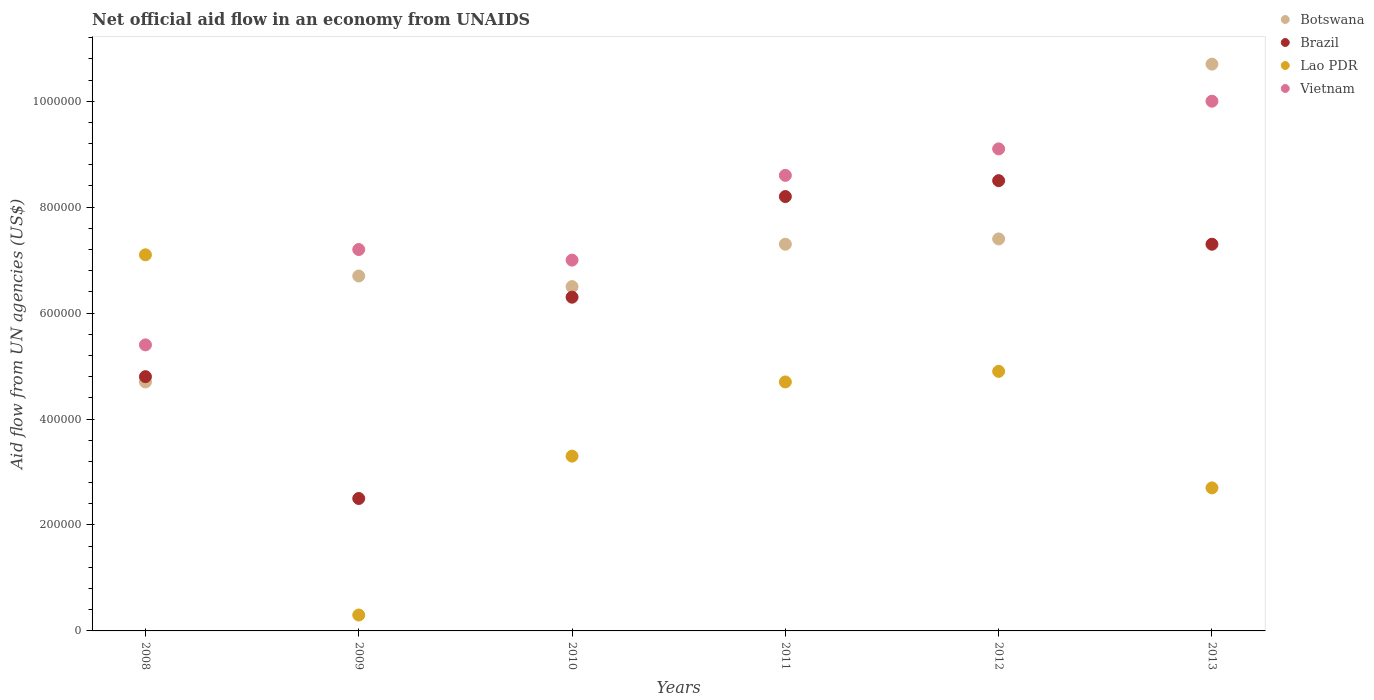How many different coloured dotlines are there?
Make the answer very short. 4. What is the net official aid flow in Lao PDR in 2008?
Provide a short and direct response. 7.10e+05. Across all years, what is the maximum net official aid flow in Botswana?
Offer a very short reply. 1.07e+06. Across all years, what is the minimum net official aid flow in Lao PDR?
Give a very brief answer. 3.00e+04. What is the total net official aid flow in Vietnam in the graph?
Ensure brevity in your answer.  4.73e+06. What is the difference between the net official aid flow in Botswana in 2009 and that in 2012?
Provide a short and direct response. -7.00e+04. What is the difference between the net official aid flow in Brazil in 2008 and the net official aid flow in Botswana in 2012?
Provide a succinct answer. -2.60e+05. What is the average net official aid flow in Vietnam per year?
Provide a succinct answer. 7.88e+05. In the year 2010, what is the difference between the net official aid flow in Brazil and net official aid flow in Vietnam?
Keep it short and to the point. -7.00e+04. What is the ratio of the net official aid flow in Vietnam in 2008 to that in 2012?
Offer a terse response. 0.59. Is the net official aid flow in Botswana in 2011 less than that in 2012?
Your answer should be very brief. Yes. Is the difference between the net official aid flow in Brazil in 2009 and 2011 greater than the difference between the net official aid flow in Vietnam in 2009 and 2011?
Your response must be concise. No. What is the difference between the highest and the second highest net official aid flow in Vietnam?
Your answer should be compact. 9.00e+04. What is the difference between the highest and the lowest net official aid flow in Vietnam?
Your response must be concise. 4.60e+05. In how many years, is the net official aid flow in Botswana greater than the average net official aid flow in Botswana taken over all years?
Provide a short and direct response. 3. Is the sum of the net official aid flow in Botswana in 2008 and 2010 greater than the maximum net official aid flow in Vietnam across all years?
Offer a very short reply. Yes. Is it the case that in every year, the sum of the net official aid flow in Brazil and net official aid flow in Vietnam  is greater than the net official aid flow in Lao PDR?
Make the answer very short. Yes. Is the net official aid flow in Vietnam strictly greater than the net official aid flow in Brazil over the years?
Keep it short and to the point. Yes. What is the difference between two consecutive major ticks on the Y-axis?
Provide a short and direct response. 2.00e+05. Does the graph contain grids?
Give a very brief answer. No. How many legend labels are there?
Your answer should be compact. 4. How are the legend labels stacked?
Offer a very short reply. Vertical. What is the title of the graph?
Your answer should be very brief. Net official aid flow in an economy from UNAIDS. What is the label or title of the X-axis?
Ensure brevity in your answer.  Years. What is the label or title of the Y-axis?
Your response must be concise. Aid flow from UN agencies (US$). What is the Aid flow from UN agencies (US$) in Botswana in 2008?
Offer a very short reply. 4.70e+05. What is the Aid flow from UN agencies (US$) in Brazil in 2008?
Make the answer very short. 4.80e+05. What is the Aid flow from UN agencies (US$) of Lao PDR in 2008?
Make the answer very short. 7.10e+05. What is the Aid flow from UN agencies (US$) in Vietnam in 2008?
Your answer should be very brief. 5.40e+05. What is the Aid flow from UN agencies (US$) in Botswana in 2009?
Give a very brief answer. 6.70e+05. What is the Aid flow from UN agencies (US$) of Lao PDR in 2009?
Provide a succinct answer. 3.00e+04. What is the Aid flow from UN agencies (US$) in Vietnam in 2009?
Provide a succinct answer. 7.20e+05. What is the Aid flow from UN agencies (US$) of Botswana in 2010?
Provide a short and direct response. 6.50e+05. What is the Aid flow from UN agencies (US$) of Brazil in 2010?
Your answer should be compact. 6.30e+05. What is the Aid flow from UN agencies (US$) of Lao PDR in 2010?
Keep it short and to the point. 3.30e+05. What is the Aid flow from UN agencies (US$) in Botswana in 2011?
Provide a short and direct response. 7.30e+05. What is the Aid flow from UN agencies (US$) in Brazil in 2011?
Ensure brevity in your answer.  8.20e+05. What is the Aid flow from UN agencies (US$) in Vietnam in 2011?
Provide a short and direct response. 8.60e+05. What is the Aid flow from UN agencies (US$) in Botswana in 2012?
Offer a very short reply. 7.40e+05. What is the Aid flow from UN agencies (US$) of Brazil in 2012?
Offer a very short reply. 8.50e+05. What is the Aid flow from UN agencies (US$) of Vietnam in 2012?
Provide a succinct answer. 9.10e+05. What is the Aid flow from UN agencies (US$) of Botswana in 2013?
Keep it short and to the point. 1.07e+06. What is the Aid flow from UN agencies (US$) of Brazil in 2013?
Your answer should be very brief. 7.30e+05. What is the Aid flow from UN agencies (US$) of Vietnam in 2013?
Offer a terse response. 1.00e+06. Across all years, what is the maximum Aid flow from UN agencies (US$) of Botswana?
Offer a very short reply. 1.07e+06. Across all years, what is the maximum Aid flow from UN agencies (US$) of Brazil?
Provide a short and direct response. 8.50e+05. Across all years, what is the maximum Aid flow from UN agencies (US$) in Lao PDR?
Your answer should be compact. 7.10e+05. Across all years, what is the maximum Aid flow from UN agencies (US$) in Vietnam?
Your answer should be very brief. 1.00e+06. Across all years, what is the minimum Aid flow from UN agencies (US$) in Botswana?
Provide a short and direct response. 4.70e+05. Across all years, what is the minimum Aid flow from UN agencies (US$) in Brazil?
Make the answer very short. 2.50e+05. Across all years, what is the minimum Aid flow from UN agencies (US$) of Lao PDR?
Offer a very short reply. 3.00e+04. Across all years, what is the minimum Aid flow from UN agencies (US$) of Vietnam?
Your response must be concise. 5.40e+05. What is the total Aid flow from UN agencies (US$) of Botswana in the graph?
Your answer should be very brief. 4.33e+06. What is the total Aid flow from UN agencies (US$) of Brazil in the graph?
Provide a succinct answer. 3.76e+06. What is the total Aid flow from UN agencies (US$) in Lao PDR in the graph?
Offer a terse response. 2.30e+06. What is the total Aid flow from UN agencies (US$) of Vietnam in the graph?
Provide a succinct answer. 4.73e+06. What is the difference between the Aid flow from UN agencies (US$) of Lao PDR in 2008 and that in 2009?
Offer a terse response. 6.80e+05. What is the difference between the Aid flow from UN agencies (US$) of Vietnam in 2008 and that in 2009?
Your response must be concise. -1.80e+05. What is the difference between the Aid flow from UN agencies (US$) in Lao PDR in 2008 and that in 2010?
Your response must be concise. 3.80e+05. What is the difference between the Aid flow from UN agencies (US$) in Vietnam in 2008 and that in 2010?
Your response must be concise. -1.60e+05. What is the difference between the Aid flow from UN agencies (US$) of Botswana in 2008 and that in 2011?
Your response must be concise. -2.60e+05. What is the difference between the Aid flow from UN agencies (US$) of Vietnam in 2008 and that in 2011?
Provide a succinct answer. -3.20e+05. What is the difference between the Aid flow from UN agencies (US$) of Botswana in 2008 and that in 2012?
Your answer should be compact. -2.70e+05. What is the difference between the Aid flow from UN agencies (US$) in Brazil in 2008 and that in 2012?
Your answer should be compact. -3.70e+05. What is the difference between the Aid flow from UN agencies (US$) in Lao PDR in 2008 and that in 2012?
Your answer should be compact. 2.20e+05. What is the difference between the Aid flow from UN agencies (US$) of Vietnam in 2008 and that in 2012?
Your answer should be compact. -3.70e+05. What is the difference between the Aid flow from UN agencies (US$) of Botswana in 2008 and that in 2013?
Your response must be concise. -6.00e+05. What is the difference between the Aid flow from UN agencies (US$) of Brazil in 2008 and that in 2013?
Offer a terse response. -2.50e+05. What is the difference between the Aid flow from UN agencies (US$) of Vietnam in 2008 and that in 2013?
Your answer should be compact. -4.60e+05. What is the difference between the Aid flow from UN agencies (US$) in Botswana in 2009 and that in 2010?
Offer a terse response. 2.00e+04. What is the difference between the Aid flow from UN agencies (US$) in Brazil in 2009 and that in 2010?
Your answer should be compact. -3.80e+05. What is the difference between the Aid flow from UN agencies (US$) of Lao PDR in 2009 and that in 2010?
Provide a short and direct response. -3.00e+05. What is the difference between the Aid flow from UN agencies (US$) in Vietnam in 2009 and that in 2010?
Ensure brevity in your answer.  2.00e+04. What is the difference between the Aid flow from UN agencies (US$) in Brazil in 2009 and that in 2011?
Make the answer very short. -5.70e+05. What is the difference between the Aid flow from UN agencies (US$) in Lao PDR in 2009 and that in 2011?
Ensure brevity in your answer.  -4.40e+05. What is the difference between the Aid flow from UN agencies (US$) in Vietnam in 2009 and that in 2011?
Your answer should be very brief. -1.40e+05. What is the difference between the Aid flow from UN agencies (US$) of Brazil in 2009 and that in 2012?
Your answer should be very brief. -6.00e+05. What is the difference between the Aid flow from UN agencies (US$) of Lao PDR in 2009 and that in 2012?
Provide a short and direct response. -4.60e+05. What is the difference between the Aid flow from UN agencies (US$) in Botswana in 2009 and that in 2013?
Your answer should be compact. -4.00e+05. What is the difference between the Aid flow from UN agencies (US$) of Brazil in 2009 and that in 2013?
Your answer should be very brief. -4.80e+05. What is the difference between the Aid flow from UN agencies (US$) of Lao PDR in 2009 and that in 2013?
Keep it short and to the point. -2.40e+05. What is the difference between the Aid flow from UN agencies (US$) of Vietnam in 2009 and that in 2013?
Give a very brief answer. -2.80e+05. What is the difference between the Aid flow from UN agencies (US$) in Brazil in 2010 and that in 2011?
Your answer should be compact. -1.90e+05. What is the difference between the Aid flow from UN agencies (US$) of Lao PDR in 2010 and that in 2011?
Provide a short and direct response. -1.40e+05. What is the difference between the Aid flow from UN agencies (US$) in Botswana in 2010 and that in 2012?
Your answer should be compact. -9.00e+04. What is the difference between the Aid flow from UN agencies (US$) of Lao PDR in 2010 and that in 2012?
Offer a very short reply. -1.60e+05. What is the difference between the Aid flow from UN agencies (US$) of Botswana in 2010 and that in 2013?
Your answer should be compact. -4.20e+05. What is the difference between the Aid flow from UN agencies (US$) of Lao PDR in 2010 and that in 2013?
Offer a terse response. 6.00e+04. What is the difference between the Aid flow from UN agencies (US$) of Botswana in 2011 and that in 2012?
Keep it short and to the point. -10000. What is the difference between the Aid flow from UN agencies (US$) of Lao PDR in 2011 and that in 2012?
Give a very brief answer. -2.00e+04. What is the difference between the Aid flow from UN agencies (US$) in Vietnam in 2011 and that in 2012?
Provide a succinct answer. -5.00e+04. What is the difference between the Aid flow from UN agencies (US$) in Botswana in 2011 and that in 2013?
Make the answer very short. -3.40e+05. What is the difference between the Aid flow from UN agencies (US$) of Vietnam in 2011 and that in 2013?
Offer a very short reply. -1.40e+05. What is the difference between the Aid flow from UN agencies (US$) in Botswana in 2012 and that in 2013?
Keep it short and to the point. -3.30e+05. What is the difference between the Aid flow from UN agencies (US$) in Vietnam in 2012 and that in 2013?
Offer a very short reply. -9.00e+04. What is the difference between the Aid flow from UN agencies (US$) of Botswana in 2008 and the Aid flow from UN agencies (US$) of Brazil in 2009?
Offer a very short reply. 2.20e+05. What is the difference between the Aid flow from UN agencies (US$) of Brazil in 2008 and the Aid flow from UN agencies (US$) of Lao PDR in 2009?
Provide a short and direct response. 4.50e+05. What is the difference between the Aid flow from UN agencies (US$) in Lao PDR in 2008 and the Aid flow from UN agencies (US$) in Vietnam in 2009?
Your response must be concise. -10000. What is the difference between the Aid flow from UN agencies (US$) of Botswana in 2008 and the Aid flow from UN agencies (US$) of Lao PDR in 2010?
Give a very brief answer. 1.40e+05. What is the difference between the Aid flow from UN agencies (US$) of Botswana in 2008 and the Aid flow from UN agencies (US$) of Brazil in 2011?
Provide a short and direct response. -3.50e+05. What is the difference between the Aid flow from UN agencies (US$) in Botswana in 2008 and the Aid flow from UN agencies (US$) in Lao PDR in 2011?
Your response must be concise. 0. What is the difference between the Aid flow from UN agencies (US$) of Botswana in 2008 and the Aid flow from UN agencies (US$) of Vietnam in 2011?
Your response must be concise. -3.90e+05. What is the difference between the Aid flow from UN agencies (US$) of Brazil in 2008 and the Aid flow from UN agencies (US$) of Vietnam in 2011?
Offer a terse response. -3.80e+05. What is the difference between the Aid flow from UN agencies (US$) of Lao PDR in 2008 and the Aid flow from UN agencies (US$) of Vietnam in 2011?
Your answer should be very brief. -1.50e+05. What is the difference between the Aid flow from UN agencies (US$) in Botswana in 2008 and the Aid flow from UN agencies (US$) in Brazil in 2012?
Provide a short and direct response. -3.80e+05. What is the difference between the Aid flow from UN agencies (US$) in Botswana in 2008 and the Aid flow from UN agencies (US$) in Vietnam in 2012?
Provide a short and direct response. -4.40e+05. What is the difference between the Aid flow from UN agencies (US$) in Brazil in 2008 and the Aid flow from UN agencies (US$) in Vietnam in 2012?
Make the answer very short. -4.30e+05. What is the difference between the Aid flow from UN agencies (US$) in Botswana in 2008 and the Aid flow from UN agencies (US$) in Brazil in 2013?
Ensure brevity in your answer.  -2.60e+05. What is the difference between the Aid flow from UN agencies (US$) in Botswana in 2008 and the Aid flow from UN agencies (US$) in Vietnam in 2013?
Keep it short and to the point. -5.30e+05. What is the difference between the Aid flow from UN agencies (US$) of Brazil in 2008 and the Aid flow from UN agencies (US$) of Vietnam in 2013?
Your response must be concise. -5.20e+05. What is the difference between the Aid flow from UN agencies (US$) in Botswana in 2009 and the Aid flow from UN agencies (US$) in Brazil in 2010?
Offer a very short reply. 4.00e+04. What is the difference between the Aid flow from UN agencies (US$) of Botswana in 2009 and the Aid flow from UN agencies (US$) of Lao PDR in 2010?
Provide a succinct answer. 3.40e+05. What is the difference between the Aid flow from UN agencies (US$) in Brazil in 2009 and the Aid flow from UN agencies (US$) in Vietnam in 2010?
Your answer should be very brief. -4.50e+05. What is the difference between the Aid flow from UN agencies (US$) in Lao PDR in 2009 and the Aid flow from UN agencies (US$) in Vietnam in 2010?
Your answer should be compact. -6.70e+05. What is the difference between the Aid flow from UN agencies (US$) in Brazil in 2009 and the Aid flow from UN agencies (US$) in Lao PDR in 2011?
Provide a succinct answer. -2.20e+05. What is the difference between the Aid flow from UN agencies (US$) in Brazil in 2009 and the Aid flow from UN agencies (US$) in Vietnam in 2011?
Offer a terse response. -6.10e+05. What is the difference between the Aid flow from UN agencies (US$) of Lao PDR in 2009 and the Aid flow from UN agencies (US$) of Vietnam in 2011?
Make the answer very short. -8.30e+05. What is the difference between the Aid flow from UN agencies (US$) of Botswana in 2009 and the Aid flow from UN agencies (US$) of Vietnam in 2012?
Give a very brief answer. -2.40e+05. What is the difference between the Aid flow from UN agencies (US$) in Brazil in 2009 and the Aid flow from UN agencies (US$) in Vietnam in 2012?
Give a very brief answer. -6.60e+05. What is the difference between the Aid flow from UN agencies (US$) of Lao PDR in 2009 and the Aid flow from UN agencies (US$) of Vietnam in 2012?
Provide a succinct answer. -8.80e+05. What is the difference between the Aid flow from UN agencies (US$) in Botswana in 2009 and the Aid flow from UN agencies (US$) in Lao PDR in 2013?
Keep it short and to the point. 4.00e+05. What is the difference between the Aid flow from UN agencies (US$) of Botswana in 2009 and the Aid flow from UN agencies (US$) of Vietnam in 2013?
Your response must be concise. -3.30e+05. What is the difference between the Aid flow from UN agencies (US$) in Brazil in 2009 and the Aid flow from UN agencies (US$) in Lao PDR in 2013?
Offer a terse response. -2.00e+04. What is the difference between the Aid flow from UN agencies (US$) of Brazil in 2009 and the Aid flow from UN agencies (US$) of Vietnam in 2013?
Provide a succinct answer. -7.50e+05. What is the difference between the Aid flow from UN agencies (US$) of Lao PDR in 2009 and the Aid flow from UN agencies (US$) of Vietnam in 2013?
Offer a terse response. -9.70e+05. What is the difference between the Aid flow from UN agencies (US$) in Brazil in 2010 and the Aid flow from UN agencies (US$) in Vietnam in 2011?
Your response must be concise. -2.30e+05. What is the difference between the Aid flow from UN agencies (US$) of Lao PDR in 2010 and the Aid flow from UN agencies (US$) of Vietnam in 2011?
Ensure brevity in your answer.  -5.30e+05. What is the difference between the Aid flow from UN agencies (US$) in Botswana in 2010 and the Aid flow from UN agencies (US$) in Brazil in 2012?
Your response must be concise. -2.00e+05. What is the difference between the Aid flow from UN agencies (US$) in Brazil in 2010 and the Aid flow from UN agencies (US$) in Vietnam in 2012?
Your answer should be very brief. -2.80e+05. What is the difference between the Aid flow from UN agencies (US$) in Lao PDR in 2010 and the Aid flow from UN agencies (US$) in Vietnam in 2012?
Give a very brief answer. -5.80e+05. What is the difference between the Aid flow from UN agencies (US$) of Botswana in 2010 and the Aid flow from UN agencies (US$) of Vietnam in 2013?
Your answer should be very brief. -3.50e+05. What is the difference between the Aid flow from UN agencies (US$) in Brazil in 2010 and the Aid flow from UN agencies (US$) in Vietnam in 2013?
Your response must be concise. -3.70e+05. What is the difference between the Aid flow from UN agencies (US$) in Lao PDR in 2010 and the Aid flow from UN agencies (US$) in Vietnam in 2013?
Keep it short and to the point. -6.70e+05. What is the difference between the Aid flow from UN agencies (US$) of Botswana in 2011 and the Aid flow from UN agencies (US$) of Brazil in 2012?
Ensure brevity in your answer.  -1.20e+05. What is the difference between the Aid flow from UN agencies (US$) of Botswana in 2011 and the Aid flow from UN agencies (US$) of Lao PDR in 2012?
Give a very brief answer. 2.40e+05. What is the difference between the Aid flow from UN agencies (US$) of Brazil in 2011 and the Aid flow from UN agencies (US$) of Lao PDR in 2012?
Your answer should be compact. 3.30e+05. What is the difference between the Aid flow from UN agencies (US$) in Brazil in 2011 and the Aid flow from UN agencies (US$) in Vietnam in 2012?
Provide a succinct answer. -9.00e+04. What is the difference between the Aid flow from UN agencies (US$) of Lao PDR in 2011 and the Aid flow from UN agencies (US$) of Vietnam in 2012?
Ensure brevity in your answer.  -4.40e+05. What is the difference between the Aid flow from UN agencies (US$) of Botswana in 2011 and the Aid flow from UN agencies (US$) of Vietnam in 2013?
Provide a short and direct response. -2.70e+05. What is the difference between the Aid flow from UN agencies (US$) in Brazil in 2011 and the Aid flow from UN agencies (US$) in Vietnam in 2013?
Keep it short and to the point. -1.80e+05. What is the difference between the Aid flow from UN agencies (US$) in Lao PDR in 2011 and the Aid flow from UN agencies (US$) in Vietnam in 2013?
Provide a short and direct response. -5.30e+05. What is the difference between the Aid flow from UN agencies (US$) in Botswana in 2012 and the Aid flow from UN agencies (US$) in Brazil in 2013?
Give a very brief answer. 10000. What is the difference between the Aid flow from UN agencies (US$) in Botswana in 2012 and the Aid flow from UN agencies (US$) in Lao PDR in 2013?
Provide a short and direct response. 4.70e+05. What is the difference between the Aid flow from UN agencies (US$) in Brazil in 2012 and the Aid flow from UN agencies (US$) in Lao PDR in 2013?
Keep it short and to the point. 5.80e+05. What is the difference between the Aid flow from UN agencies (US$) of Lao PDR in 2012 and the Aid flow from UN agencies (US$) of Vietnam in 2013?
Provide a short and direct response. -5.10e+05. What is the average Aid flow from UN agencies (US$) in Botswana per year?
Keep it short and to the point. 7.22e+05. What is the average Aid flow from UN agencies (US$) in Brazil per year?
Offer a very short reply. 6.27e+05. What is the average Aid flow from UN agencies (US$) in Lao PDR per year?
Your answer should be very brief. 3.83e+05. What is the average Aid flow from UN agencies (US$) in Vietnam per year?
Offer a very short reply. 7.88e+05. In the year 2008, what is the difference between the Aid flow from UN agencies (US$) in Botswana and Aid flow from UN agencies (US$) in Brazil?
Ensure brevity in your answer.  -10000. In the year 2008, what is the difference between the Aid flow from UN agencies (US$) of Botswana and Aid flow from UN agencies (US$) of Vietnam?
Offer a terse response. -7.00e+04. In the year 2008, what is the difference between the Aid flow from UN agencies (US$) in Brazil and Aid flow from UN agencies (US$) in Vietnam?
Ensure brevity in your answer.  -6.00e+04. In the year 2009, what is the difference between the Aid flow from UN agencies (US$) in Botswana and Aid flow from UN agencies (US$) in Brazil?
Keep it short and to the point. 4.20e+05. In the year 2009, what is the difference between the Aid flow from UN agencies (US$) in Botswana and Aid flow from UN agencies (US$) in Lao PDR?
Your answer should be very brief. 6.40e+05. In the year 2009, what is the difference between the Aid flow from UN agencies (US$) in Brazil and Aid flow from UN agencies (US$) in Vietnam?
Keep it short and to the point. -4.70e+05. In the year 2009, what is the difference between the Aid flow from UN agencies (US$) of Lao PDR and Aid flow from UN agencies (US$) of Vietnam?
Ensure brevity in your answer.  -6.90e+05. In the year 2010, what is the difference between the Aid flow from UN agencies (US$) of Botswana and Aid flow from UN agencies (US$) of Lao PDR?
Offer a terse response. 3.20e+05. In the year 2010, what is the difference between the Aid flow from UN agencies (US$) of Brazil and Aid flow from UN agencies (US$) of Lao PDR?
Offer a very short reply. 3.00e+05. In the year 2010, what is the difference between the Aid flow from UN agencies (US$) in Brazil and Aid flow from UN agencies (US$) in Vietnam?
Give a very brief answer. -7.00e+04. In the year 2010, what is the difference between the Aid flow from UN agencies (US$) in Lao PDR and Aid flow from UN agencies (US$) in Vietnam?
Provide a succinct answer. -3.70e+05. In the year 2011, what is the difference between the Aid flow from UN agencies (US$) in Botswana and Aid flow from UN agencies (US$) in Brazil?
Your answer should be compact. -9.00e+04. In the year 2011, what is the difference between the Aid flow from UN agencies (US$) in Botswana and Aid flow from UN agencies (US$) in Lao PDR?
Give a very brief answer. 2.60e+05. In the year 2011, what is the difference between the Aid flow from UN agencies (US$) in Botswana and Aid flow from UN agencies (US$) in Vietnam?
Offer a very short reply. -1.30e+05. In the year 2011, what is the difference between the Aid flow from UN agencies (US$) of Lao PDR and Aid flow from UN agencies (US$) of Vietnam?
Your response must be concise. -3.90e+05. In the year 2012, what is the difference between the Aid flow from UN agencies (US$) in Botswana and Aid flow from UN agencies (US$) in Brazil?
Your answer should be very brief. -1.10e+05. In the year 2012, what is the difference between the Aid flow from UN agencies (US$) in Botswana and Aid flow from UN agencies (US$) in Lao PDR?
Keep it short and to the point. 2.50e+05. In the year 2012, what is the difference between the Aid flow from UN agencies (US$) of Botswana and Aid flow from UN agencies (US$) of Vietnam?
Your answer should be very brief. -1.70e+05. In the year 2012, what is the difference between the Aid flow from UN agencies (US$) of Brazil and Aid flow from UN agencies (US$) of Vietnam?
Your answer should be compact. -6.00e+04. In the year 2012, what is the difference between the Aid flow from UN agencies (US$) in Lao PDR and Aid flow from UN agencies (US$) in Vietnam?
Provide a succinct answer. -4.20e+05. In the year 2013, what is the difference between the Aid flow from UN agencies (US$) in Botswana and Aid flow from UN agencies (US$) in Brazil?
Ensure brevity in your answer.  3.40e+05. In the year 2013, what is the difference between the Aid flow from UN agencies (US$) in Botswana and Aid flow from UN agencies (US$) in Lao PDR?
Make the answer very short. 8.00e+05. In the year 2013, what is the difference between the Aid flow from UN agencies (US$) in Botswana and Aid flow from UN agencies (US$) in Vietnam?
Offer a very short reply. 7.00e+04. In the year 2013, what is the difference between the Aid flow from UN agencies (US$) in Brazil and Aid flow from UN agencies (US$) in Vietnam?
Give a very brief answer. -2.70e+05. In the year 2013, what is the difference between the Aid flow from UN agencies (US$) of Lao PDR and Aid flow from UN agencies (US$) of Vietnam?
Ensure brevity in your answer.  -7.30e+05. What is the ratio of the Aid flow from UN agencies (US$) in Botswana in 2008 to that in 2009?
Make the answer very short. 0.7. What is the ratio of the Aid flow from UN agencies (US$) in Brazil in 2008 to that in 2009?
Keep it short and to the point. 1.92. What is the ratio of the Aid flow from UN agencies (US$) in Lao PDR in 2008 to that in 2009?
Your response must be concise. 23.67. What is the ratio of the Aid flow from UN agencies (US$) of Vietnam in 2008 to that in 2009?
Offer a very short reply. 0.75. What is the ratio of the Aid flow from UN agencies (US$) in Botswana in 2008 to that in 2010?
Offer a terse response. 0.72. What is the ratio of the Aid flow from UN agencies (US$) in Brazil in 2008 to that in 2010?
Give a very brief answer. 0.76. What is the ratio of the Aid flow from UN agencies (US$) in Lao PDR in 2008 to that in 2010?
Ensure brevity in your answer.  2.15. What is the ratio of the Aid flow from UN agencies (US$) in Vietnam in 2008 to that in 2010?
Your answer should be very brief. 0.77. What is the ratio of the Aid flow from UN agencies (US$) in Botswana in 2008 to that in 2011?
Make the answer very short. 0.64. What is the ratio of the Aid flow from UN agencies (US$) in Brazil in 2008 to that in 2011?
Give a very brief answer. 0.59. What is the ratio of the Aid flow from UN agencies (US$) of Lao PDR in 2008 to that in 2011?
Offer a terse response. 1.51. What is the ratio of the Aid flow from UN agencies (US$) in Vietnam in 2008 to that in 2011?
Your answer should be very brief. 0.63. What is the ratio of the Aid flow from UN agencies (US$) of Botswana in 2008 to that in 2012?
Keep it short and to the point. 0.64. What is the ratio of the Aid flow from UN agencies (US$) of Brazil in 2008 to that in 2012?
Make the answer very short. 0.56. What is the ratio of the Aid flow from UN agencies (US$) in Lao PDR in 2008 to that in 2012?
Keep it short and to the point. 1.45. What is the ratio of the Aid flow from UN agencies (US$) in Vietnam in 2008 to that in 2012?
Provide a succinct answer. 0.59. What is the ratio of the Aid flow from UN agencies (US$) of Botswana in 2008 to that in 2013?
Make the answer very short. 0.44. What is the ratio of the Aid flow from UN agencies (US$) of Brazil in 2008 to that in 2013?
Your answer should be compact. 0.66. What is the ratio of the Aid flow from UN agencies (US$) in Lao PDR in 2008 to that in 2013?
Your answer should be compact. 2.63. What is the ratio of the Aid flow from UN agencies (US$) in Vietnam in 2008 to that in 2013?
Give a very brief answer. 0.54. What is the ratio of the Aid flow from UN agencies (US$) in Botswana in 2009 to that in 2010?
Make the answer very short. 1.03. What is the ratio of the Aid flow from UN agencies (US$) of Brazil in 2009 to that in 2010?
Your response must be concise. 0.4. What is the ratio of the Aid flow from UN agencies (US$) in Lao PDR in 2009 to that in 2010?
Provide a succinct answer. 0.09. What is the ratio of the Aid flow from UN agencies (US$) of Vietnam in 2009 to that in 2010?
Keep it short and to the point. 1.03. What is the ratio of the Aid flow from UN agencies (US$) in Botswana in 2009 to that in 2011?
Offer a very short reply. 0.92. What is the ratio of the Aid flow from UN agencies (US$) of Brazil in 2009 to that in 2011?
Offer a terse response. 0.3. What is the ratio of the Aid flow from UN agencies (US$) in Lao PDR in 2009 to that in 2011?
Your answer should be very brief. 0.06. What is the ratio of the Aid flow from UN agencies (US$) in Vietnam in 2009 to that in 2011?
Ensure brevity in your answer.  0.84. What is the ratio of the Aid flow from UN agencies (US$) in Botswana in 2009 to that in 2012?
Make the answer very short. 0.91. What is the ratio of the Aid flow from UN agencies (US$) in Brazil in 2009 to that in 2012?
Offer a very short reply. 0.29. What is the ratio of the Aid flow from UN agencies (US$) in Lao PDR in 2009 to that in 2012?
Offer a terse response. 0.06. What is the ratio of the Aid flow from UN agencies (US$) of Vietnam in 2009 to that in 2012?
Provide a succinct answer. 0.79. What is the ratio of the Aid flow from UN agencies (US$) in Botswana in 2009 to that in 2013?
Keep it short and to the point. 0.63. What is the ratio of the Aid flow from UN agencies (US$) of Brazil in 2009 to that in 2013?
Keep it short and to the point. 0.34. What is the ratio of the Aid flow from UN agencies (US$) of Vietnam in 2009 to that in 2013?
Keep it short and to the point. 0.72. What is the ratio of the Aid flow from UN agencies (US$) of Botswana in 2010 to that in 2011?
Your response must be concise. 0.89. What is the ratio of the Aid flow from UN agencies (US$) of Brazil in 2010 to that in 2011?
Make the answer very short. 0.77. What is the ratio of the Aid flow from UN agencies (US$) of Lao PDR in 2010 to that in 2011?
Your answer should be very brief. 0.7. What is the ratio of the Aid flow from UN agencies (US$) of Vietnam in 2010 to that in 2011?
Ensure brevity in your answer.  0.81. What is the ratio of the Aid flow from UN agencies (US$) of Botswana in 2010 to that in 2012?
Your answer should be very brief. 0.88. What is the ratio of the Aid flow from UN agencies (US$) of Brazil in 2010 to that in 2012?
Your answer should be compact. 0.74. What is the ratio of the Aid flow from UN agencies (US$) in Lao PDR in 2010 to that in 2012?
Provide a short and direct response. 0.67. What is the ratio of the Aid flow from UN agencies (US$) in Vietnam in 2010 to that in 2012?
Your answer should be compact. 0.77. What is the ratio of the Aid flow from UN agencies (US$) of Botswana in 2010 to that in 2013?
Your answer should be compact. 0.61. What is the ratio of the Aid flow from UN agencies (US$) in Brazil in 2010 to that in 2013?
Offer a terse response. 0.86. What is the ratio of the Aid flow from UN agencies (US$) of Lao PDR in 2010 to that in 2013?
Your response must be concise. 1.22. What is the ratio of the Aid flow from UN agencies (US$) in Vietnam in 2010 to that in 2013?
Your answer should be very brief. 0.7. What is the ratio of the Aid flow from UN agencies (US$) of Botswana in 2011 to that in 2012?
Make the answer very short. 0.99. What is the ratio of the Aid flow from UN agencies (US$) of Brazil in 2011 to that in 2012?
Offer a very short reply. 0.96. What is the ratio of the Aid flow from UN agencies (US$) of Lao PDR in 2011 to that in 2012?
Make the answer very short. 0.96. What is the ratio of the Aid flow from UN agencies (US$) of Vietnam in 2011 to that in 2012?
Your answer should be compact. 0.95. What is the ratio of the Aid flow from UN agencies (US$) of Botswana in 2011 to that in 2013?
Your response must be concise. 0.68. What is the ratio of the Aid flow from UN agencies (US$) of Brazil in 2011 to that in 2013?
Your response must be concise. 1.12. What is the ratio of the Aid flow from UN agencies (US$) in Lao PDR in 2011 to that in 2013?
Ensure brevity in your answer.  1.74. What is the ratio of the Aid flow from UN agencies (US$) in Vietnam in 2011 to that in 2013?
Your answer should be compact. 0.86. What is the ratio of the Aid flow from UN agencies (US$) of Botswana in 2012 to that in 2013?
Make the answer very short. 0.69. What is the ratio of the Aid flow from UN agencies (US$) of Brazil in 2012 to that in 2013?
Provide a succinct answer. 1.16. What is the ratio of the Aid flow from UN agencies (US$) in Lao PDR in 2012 to that in 2013?
Your response must be concise. 1.81. What is the ratio of the Aid flow from UN agencies (US$) of Vietnam in 2012 to that in 2013?
Your answer should be very brief. 0.91. What is the difference between the highest and the second highest Aid flow from UN agencies (US$) in Botswana?
Offer a terse response. 3.30e+05. What is the difference between the highest and the second highest Aid flow from UN agencies (US$) in Lao PDR?
Offer a terse response. 2.20e+05. What is the difference between the highest and the lowest Aid flow from UN agencies (US$) of Botswana?
Your answer should be compact. 6.00e+05. What is the difference between the highest and the lowest Aid flow from UN agencies (US$) in Brazil?
Make the answer very short. 6.00e+05. What is the difference between the highest and the lowest Aid flow from UN agencies (US$) in Lao PDR?
Offer a terse response. 6.80e+05. What is the difference between the highest and the lowest Aid flow from UN agencies (US$) in Vietnam?
Your answer should be compact. 4.60e+05. 